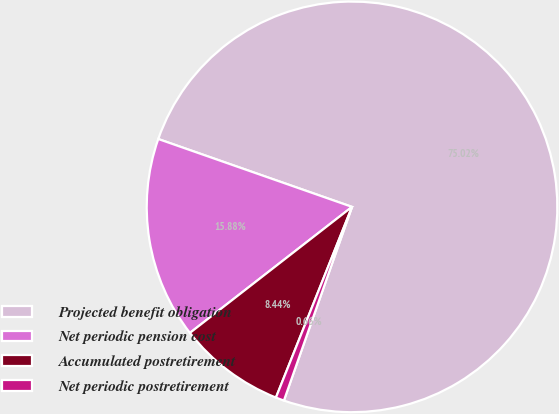Convert chart to OTSL. <chart><loc_0><loc_0><loc_500><loc_500><pie_chart><fcel>Projected benefit obligation<fcel>Net periodic pension cost<fcel>Accumulated postretirement<fcel>Net periodic postretirement<nl><fcel>75.02%<fcel>15.88%<fcel>8.44%<fcel>0.66%<nl></chart> 